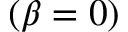<formula> <loc_0><loc_0><loc_500><loc_500>( \beta = 0 )</formula> 